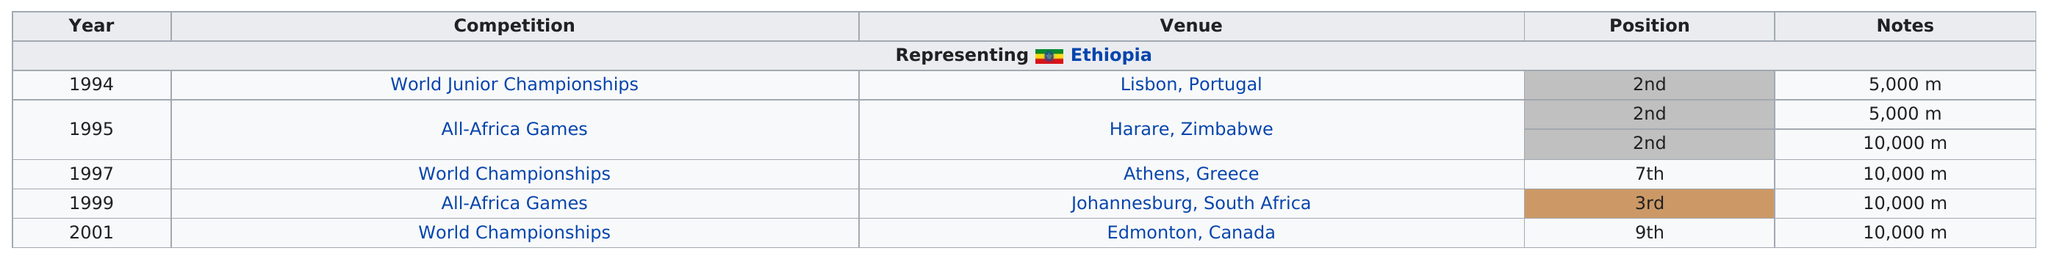Identify some key points in this picture. During the All-Africa Games, the race for the 10,000-meter distance was held. The length of the race was not specified. Habte Jifar is a marathon runner who represents his home country of Ethiopia. Jifar participated in 2 competitions before joining the 10000m. Five countries are represented as venues. Jifar has placed third or better in the 10,000 meter race two times. 